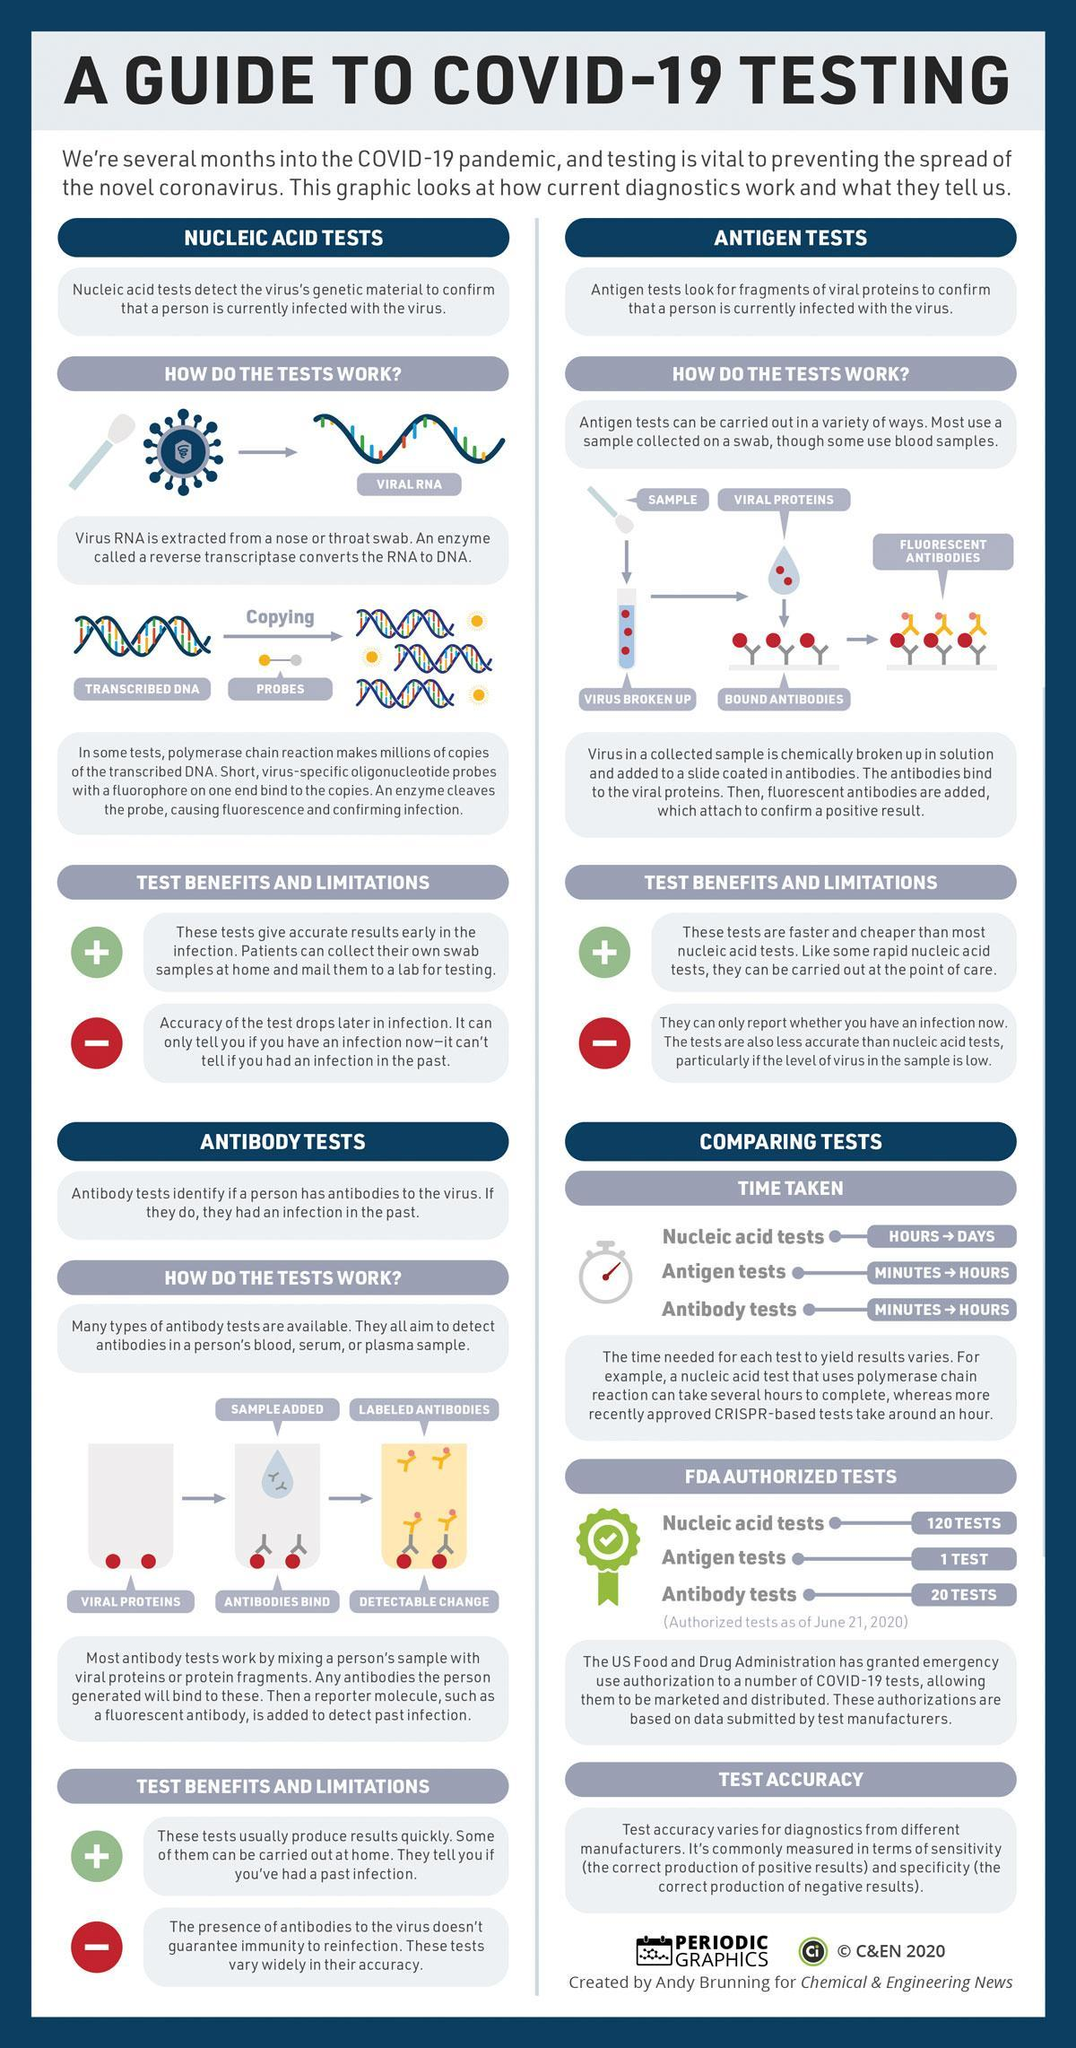Which enzyme converts RNA to DNA?
Answer the question with a short phrase. Reverse transcriptase From which all parts of the body virus RNA collected? nose, throat 